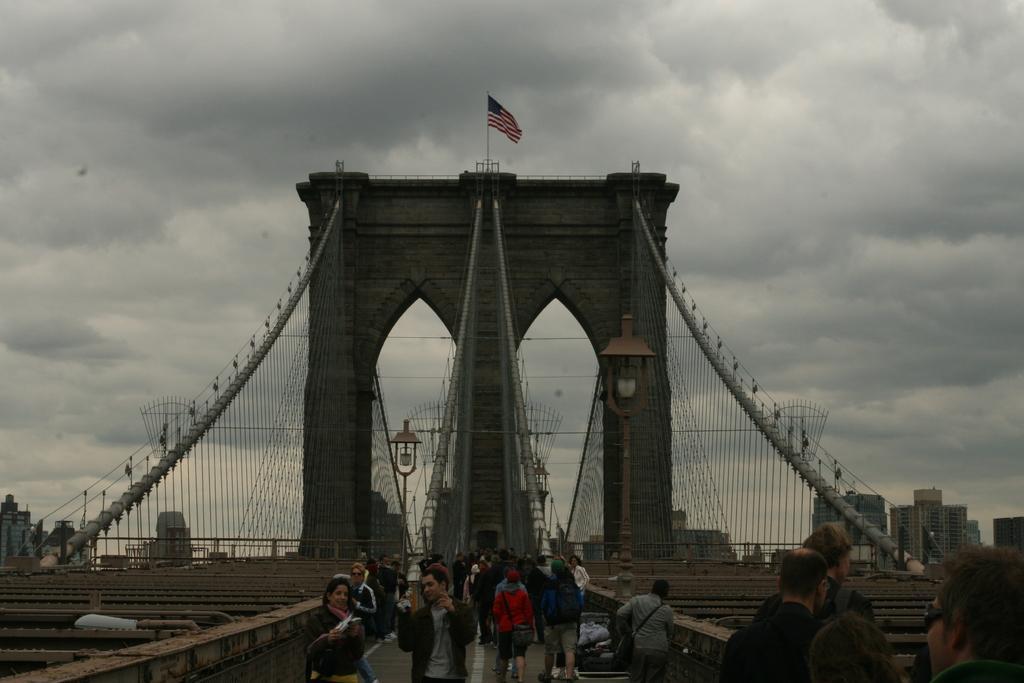Could you give a brief overview of what you see in this image? In this image in the center there is one bridge, on the bridge there are some people who are walking and some of them are standing. And in the background there are some buildings, on the right side and left side there are some poles and street light. On the top of the image there is sky and there is one flag. 